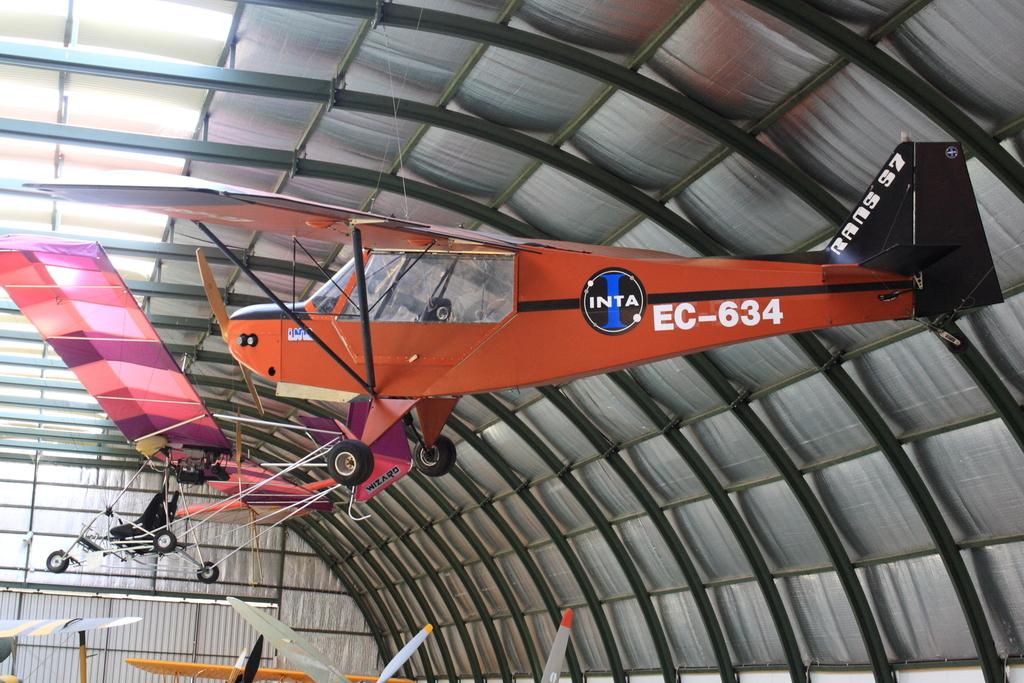Provide a one-sentence caption for the provided image. A red airplane is hanging from the roof of a hangar with the text EC-634. 